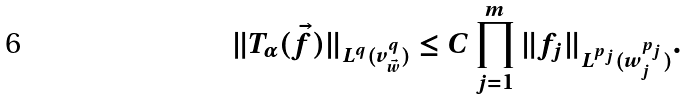Convert formula to latex. <formula><loc_0><loc_0><loc_500><loc_500>\| T _ { \alpha } ( \vec { f } ) \| _ { L ^ { q } ( v _ { \vec { w } } ^ { q } ) } & \leq C \prod _ { j = 1 } ^ { m } \| f _ { j } \| _ { L ^ { p _ { j } } ( w _ { j } ^ { p _ { j } } ) } .</formula> 